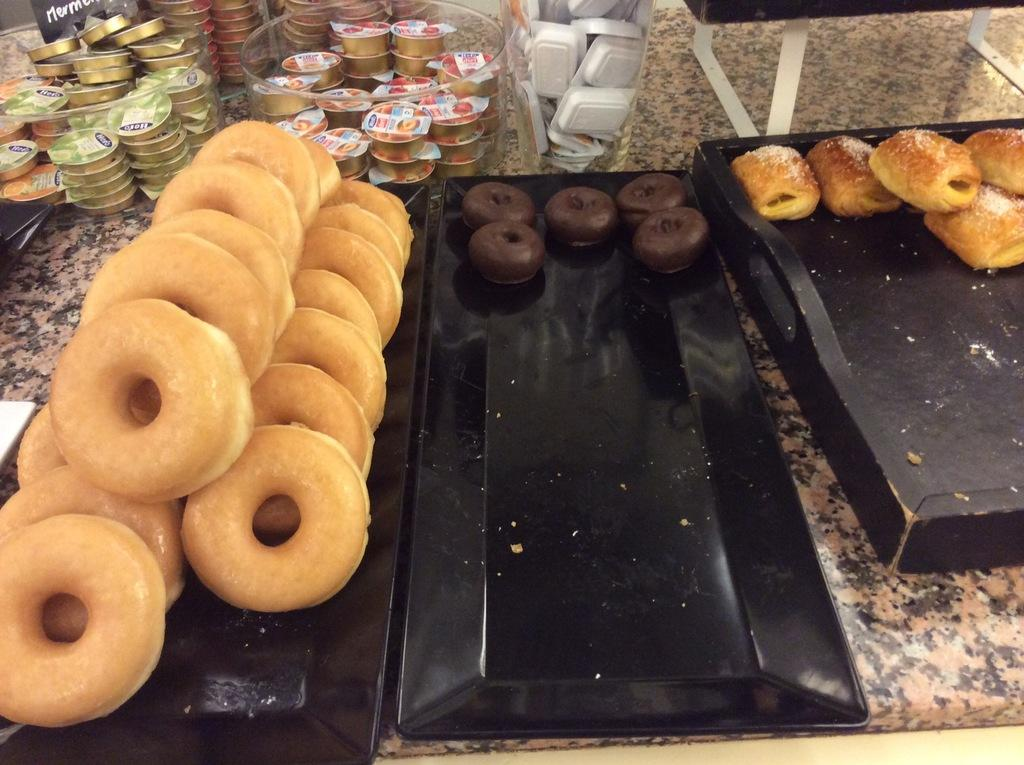What type of food items are visible in the image? There are doughnuts and puffs in the image. How are the doughnuts and puffs arranged in the image? The doughnuts and puffs are placed on trays in the image. Where are the trays with doughnuts and puffs located? The trays are placed on a surface in the image. What other items can be seen in the image besides doughnuts and puffs? There are cups and plates in the image. How are the cups and plates stored in the image? The cups and plates are inside glass containers in the image. What type of stocking is visible on the doughnuts in the image? There is no stocking present on the doughnuts in the image. What type of hospital is shown in the background of the image? There is no hospital visible in the image; it primarily features doughnuts, puffs, trays, cups, plates, and glass containers. 